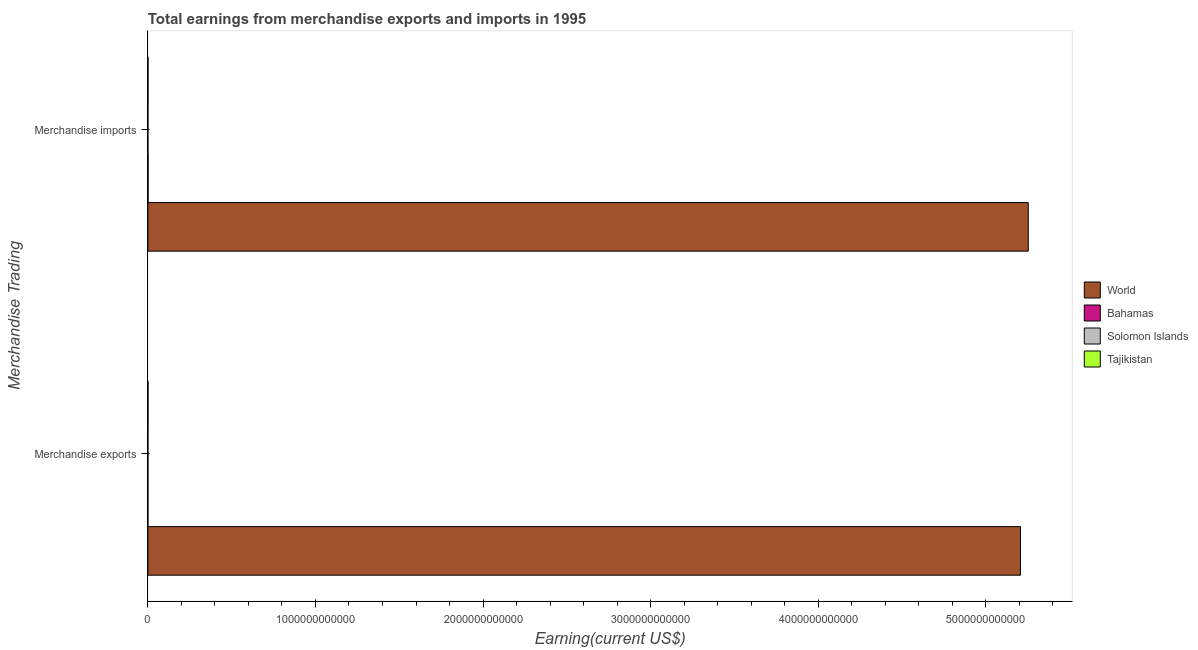Are the number of bars per tick equal to the number of legend labels?
Give a very brief answer. Yes. How many bars are there on the 2nd tick from the bottom?
Your answer should be very brief. 4. What is the earnings from merchandise exports in Bahamas?
Your response must be concise. 1.76e+08. Across all countries, what is the maximum earnings from merchandise exports?
Your answer should be compact. 5.21e+12. Across all countries, what is the minimum earnings from merchandise exports?
Your answer should be compact. 1.68e+08. In which country was the earnings from merchandise imports minimum?
Your answer should be compact. Solomon Islands. What is the total earnings from merchandise exports in the graph?
Ensure brevity in your answer.  5.21e+12. What is the difference between the earnings from merchandise imports in Bahamas and that in World?
Your response must be concise. -5.25e+12. What is the difference between the earnings from merchandise exports in Tajikistan and the earnings from merchandise imports in World?
Offer a very short reply. -5.25e+12. What is the average earnings from merchandise exports per country?
Provide a short and direct response. 1.30e+12. What is the difference between the earnings from merchandise imports and earnings from merchandise exports in Solomon Islands?
Offer a terse response. -1.40e+07. In how many countries, is the earnings from merchandise imports greater than 4000000000000 US$?
Offer a terse response. 1. What is the ratio of the earnings from merchandise exports in World to that in Tajikistan?
Provide a succinct answer. 6942.53. Is the earnings from merchandise imports in World less than that in Solomon Islands?
Ensure brevity in your answer.  No. In how many countries, is the earnings from merchandise imports greater than the average earnings from merchandise imports taken over all countries?
Provide a succinct answer. 1. What does the 3rd bar from the top in Merchandise imports represents?
Your response must be concise. Bahamas. What does the 2nd bar from the bottom in Merchandise imports represents?
Ensure brevity in your answer.  Bahamas. How many bars are there?
Offer a terse response. 8. Are all the bars in the graph horizontal?
Provide a short and direct response. Yes. What is the difference between two consecutive major ticks on the X-axis?
Provide a succinct answer. 1.00e+12. Does the graph contain any zero values?
Offer a very short reply. No. What is the title of the graph?
Provide a succinct answer. Total earnings from merchandise exports and imports in 1995. Does "Ireland" appear as one of the legend labels in the graph?
Offer a very short reply. No. What is the label or title of the X-axis?
Your answer should be compact. Earning(current US$). What is the label or title of the Y-axis?
Your response must be concise. Merchandise Trading. What is the Earning(current US$) in World in Merchandise exports?
Provide a short and direct response. 5.21e+12. What is the Earning(current US$) in Bahamas in Merchandise exports?
Provide a short and direct response. 1.76e+08. What is the Earning(current US$) in Solomon Islands in Merchandise exports?
Your response must be concise. 1.68e+08. What is the Earning(current US$) of Tajikistan in Merchandise exports?
Keep it short and to the point. 7.50e+08. What is the Earning(current US$) of World in Merchandise imports?
Offer a very short reply. 5.25e+12. What is the Earning(current US$) of Bahamas in Merchandise imports?
Your answer should be compact. 1.24e+09. What is the Earning(current US$) in Solomon Islands in Merchandise imports?
Offer a very short reply. 1.54e+08. What is the Earning(current US$) of Tajikistan in Merchandise imports?
Ensure brevity in your answer.  8.10e+08. Across all Merchandise Trading, what is the maximum Earning(current US$) of World?
Offer a very short reply. 5.25e+12. Across all Merchandise Trading, what is the maximum Earning(current US$) in Bahamas?
Ensure brevity in your answer.  1.24e+09. Across all Merchandise Trading, what is the maximum Earning(current US$) of Solomon Islands?
Your response must be concise. 1.68e+08. Across all Merchandise Trading, what is the maximum Earning(current US$) in Tajikistan?
Provide a succinct answer. 8.10e+08. Across all Merchandise Trading, what is the minimum Earning(current US$) in World?
Ensure brevity in your answer.  5.21e+12. Across all Merchandise Trading, what is the minimum Earning(current US$) of Bahamas?
Offer a terse response. 1.76e+08. Across all Merchandise Trading, what is the minimum Earning(current US$) in Solomon Islands?
Your answer should be compact. 1.54e+08. Across all Merchandise Trading, what is the minimum Earning(current US$) in Tajikistan?
Give a very brief answer. 7.50e+08. What is the total Earning(current US$) in World in the graph?
Your answer should be very brief. 1.05e+13. What is the total Earning(current US$) of Bahamas in the graph?
Keep it short and to the point. 1.42e+09. What is the total Earning(current US$) in Solomon Islands in the graph?
Make the answer very short. 3.22e+08. What is the total Earning(current US$) in Tajikistan in the graph?
Provide a short and direct response. 1.56e+09. What is the difference between the Earning(current US$) in World in Merchandise exports and that in Merchandise imports?
Provide a succinct answer. -4.62e+1. What is the difference between the Earning(current US$) in Bahamas in Merchandise exports and that in Merchandise imports?
Make the answer very short. -1.07e+09. What is the difference between the Earning(current US$) in Solomon Islands in Merchandise exports and that in Merchandise imports?
Provide a succinct answer. 1.40e+07. What is the difference between the Earning(current US$) of Tajikistan in Merchandise exports and that in Merchandise imports?
Offer a very short reply. -6.00e+07. What is the difference between the Earning(current US$) in World in Merchandise exports and the Earning(current US$) in Bahamas in Merchandise imports?
Offer a terse response. 5.21e+12. What is the difference between the Earning(current US$) of World in Merchandise exports and the Earning(current US$) of Solomon Islands in Merchandise imports?
Make the answer very short. 5.21e+12. What is the difference between the Earning(current US$) of World in Merchandise exports and the Earning(current US$) of Tajikistan in Merchandise imports?
Give a very brief answer. 5.21e+12. What is the difference between the Earning(current US$) of Bahamas in Merchandise exports and the Earning(current US$) of Solomon Islands in Merchandise imports?
Keep it short and to the point. 2.20e+07. What is the difference between the Earning(current US$) of Bahamas in Merchandise exports and the Earning(current US$) of Tajikistan in Merchandise imports?
Give a very brief answer. -6.34e+08. What is the difference between the Earning(current US$) of Solomon Islands in Merchandise exports and the Earning(current US$) of Tajikistan in Merchandise imports?
Ensure brevity in your answer.  -6.42e+08. What is the average Earning(current US$) of World per Merchandise Trading?
Offer a very short reply. 5.23e+12. What is the average Earning(current US$) of Bahamas per Merchandise Trading?
Ensure brevity in your answer.  7.10e+08. What is the average Earning(current US$) of Solomon Islands per Merchandise Trading?
Your answer should be compact. 1.61e+08. What is the average Earning(current US$) in Tajikistan per Merchandise Trading?
Keep it short and to the point. 7.80e+08. What is the difference between the Earning(current US$) in World and Earning(current US$) in Bahamas in Merchandise exports?
Keep it short and to the point. 5.21e+12. What is the difference between the Earning(current US$) in World and Earning(current US$) in Solomon Islands in Merchandise exports?
Ensure brevity in your answer.  5.21e+12. What is the difference between the Earning(current US$) in World and Earning(current US$) in Tajikistan in Merchandise exports?
Your answer should be compact. 5.21e+12. What is the difference between the Earning(current US$) in Bahamas and Earning(current US$) in Tajikistan in Merchandise exports?
Ensure brevity in your answer.  -5.74e+08. What is the difference between the Earning(current US$) of Solomon Islands and Earning(current US$) of Tajikistan in Merchandise exports?
Ensure brevity in your answer.  -5.82e+08. What is the difference between the Earning(current US$) of World and Earning(current US$) of Bahamas in Merchandise imports?
Give a very brief answer. 5.25e+12. What is the difference between the Earning(current US$) of World and Earning(current US$) of Solomon Islands in Merchandise imports?
Offer a very short reply. 5.25e+12. What is the difference between the Earning(current US$) of World and Earning(current US$) of Tajikistan in Merchandise imports?
Your response must be concise. 5.25e+12. What is the difference between the Earning(current US$) of Bahamas and Earning(current US$) of Solomon Islands in Merchandise imports?
Offer a terse response. 1.09e+09. What is the difference between the Earning(current US$) in Bahamas and Earning(current US$) in Tajikistan in Merchandise imports?
Your response must be concise. 4.33e+08. What is the difference between the Earning(current US$) in Solomon Islands and Earning(current US$) in Tajikistan in Merchandise imports?
Provide a short and direct response. -6.56e+08. What is the ratio of the Earning(current US$) in World in Merchandise exports to that in Merchandise imports?
Offer a very short reply. 0.99. What is the ratio of the Earning(current US$) of Bahamas in Merchandise exports to that in Merchandise imports?
Your answer should be compact. 0.14. What is the ratio of the Earning(current US$) of Tajikistan in Merchandise exports to that in Merchandise imports?
Ensure brevity in your answer.  0.93. What is the difference between the highest and the second highest Earning(current US$) in World?
Provide a short and direct response. 4.62e+1. What is the difference between the highest and the second highest Earning(current US$) of Bahamas?
Offer a very short reply. 1.07e+09. What is the difference between the highest and the second highest Earning(current US$) of Solomon Islands?
Your answer should be very brief. 1.40e+07. What is the difference between the highest and the second highest Earning(current US$) in Tajikistan?
Your response must be concise. 6.00e+07. What is the difference between the highest and the lowest Earning(current US$) in World?
Ensure brevity in your answer.  4.62e+1. What is the difference between the highest and the lowest Earning(current US$) of Bahamas?
Your response must be concise. 1.07e+09. What is the difference between the highest and the lowest Earning(current US$) in Solomon Islands?
Offer a very short reply. 1.40e+07. What is the difference between the highest and the lowest Earning(current US$) of Tajikistan?
Make the answer very short. 6.00e+07. 